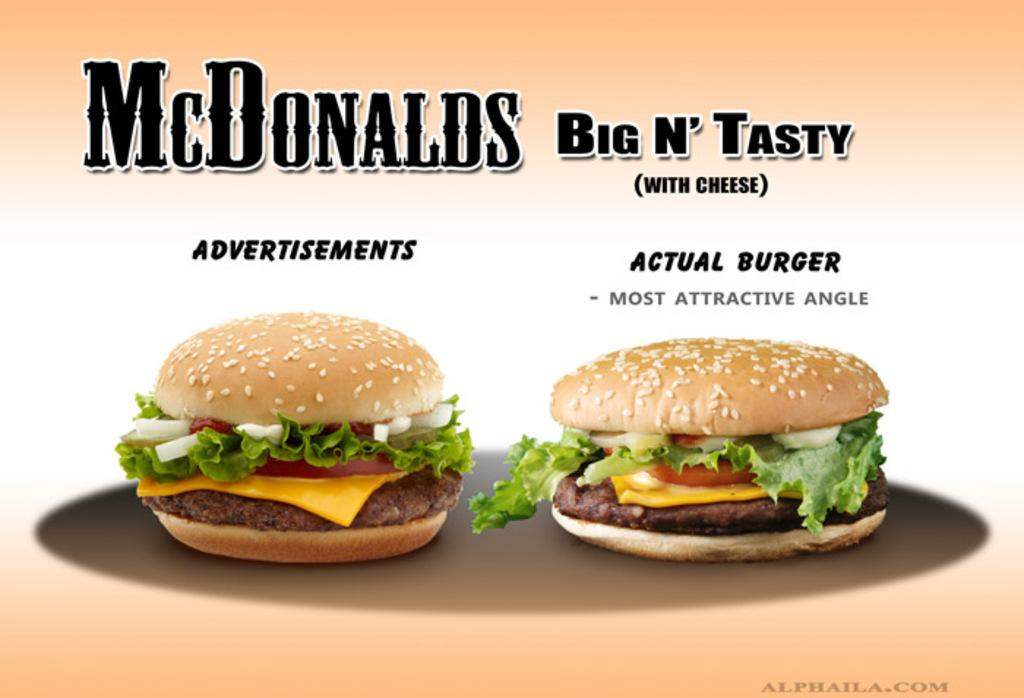What is featured on the poster in the image? The poster contains two burgers. Can you describe any additional elements on the poster? Yes, there is a watermark in the bottom right corner of the poster, and the company name is visible at the top of the poster. How many mice can be seen running around the burgers on the poster? There are no mice present on the poster; it features two burgers and other elements mentioned in the facts. 